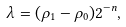Convert formula to latex. <formula><loc_0><loc_0><loc_500><loc_500>\lambda = ( \rho _ { 1 } - \rho _ { 0 } ) 2 ^ { - n } ,</formula> 